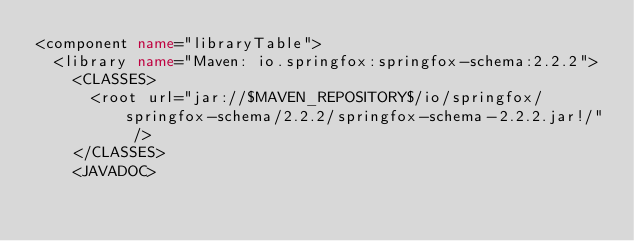<code> <loc_0><loc_0><loc_500><loc_500><_XML_><component name="libraryTable">
  <library name="Maven: io.springfox:springfox-schema:2.2.2">
    <CLASSES>
      <root url="jar://$MAVEN_REPOSITORY$/io/springfox/springfox-schema/2.2.2/springfox-schema-2.2.2.jar!/" />
    </CLASSES>
    <JAVADOC></code> 